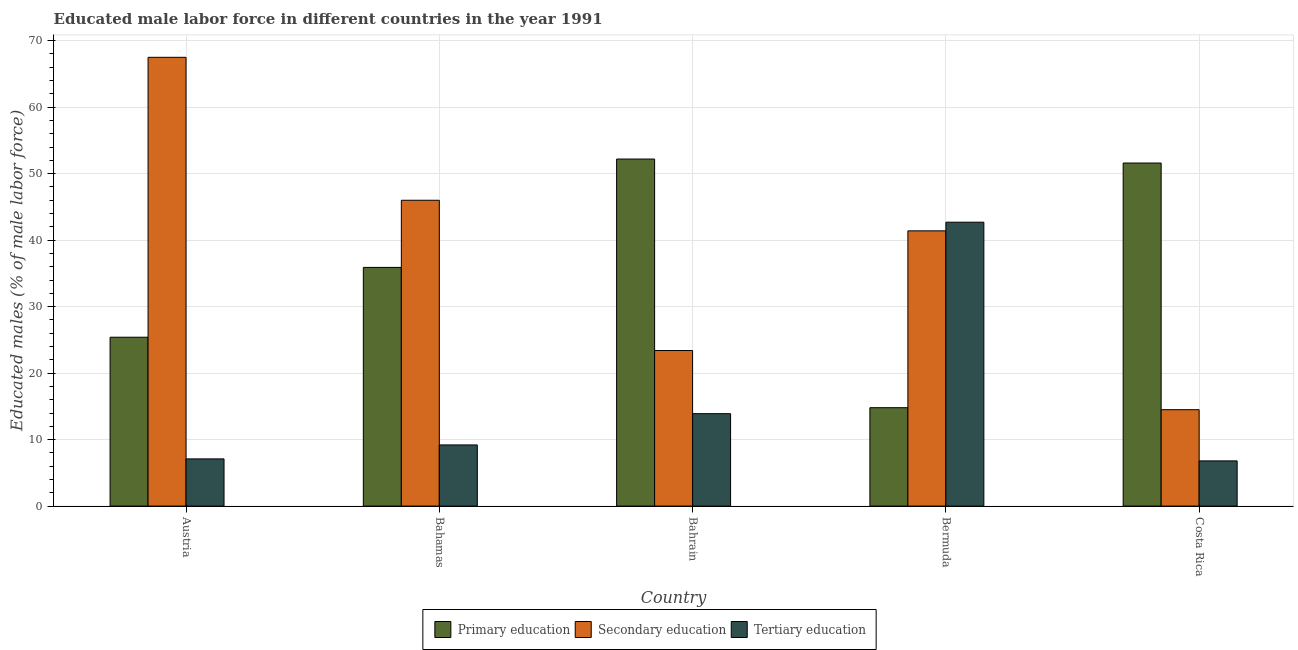What is the label of the 2nd group of bars from the left?
Give a very brief answer. Bahamas. What is the percentage of male labor force who received primary education in Austria?
Keep it short and to the point. 25.4. Across all countries, what is the maximum percentage of male labor force who received secondary education?
Provide a short and direct response. 67.5. Across all countries, what is the minimum percentage of male labor force who received primary education?
Ensure brevity in your answer.  14.8. In which country was the percentage of male labor force who received primary education maximum?
Your response must be concise. Bahrain. In which country was the percentage of male labor force who received secondary education minimum?
Your response must be concise. Costa Rica. What is the total percentage of male labor force who received secondary education in the graph?
Give a very brief answer. 192.8. What is the difference between the percentage of male labor force who received secondary education in Bermuda and the percentage of male labor force who received primary education in Austria?
Provide a succinct answer. 16. What is the average percentage of male labor force who received tertiary education per country?
Your answer should be very brief. 15.94. What is the difference between the percentage of male labor force who received primary education and percentage of male labor force who received tertiary education in Costa Rica?
Offer a terse response. 44.8. What is the ratio of the percentage of male labor force who received secondary education in Austria to that in Bermuda?
Keep it short and to the point. 1.63. Is the percentage of male labor force who received secondary education in Austria less than that in Bahrain?
Make the answer very short. No. Is the difference between the percentage of male labor force who received primary education in Bahamas and Costa Rica greater than the difference between the percentage of male labor force who received secondary education in Bahamas and Costa Rica?
Your answer should be very brief. No. What is the difference between the highest and the second highest percentage of male labor force who received tertiary education?
Your answer should be very brief. 28.8. In how many countries, is the percentage of male labor force who received secondary education greater than the average percentage of male labor force who received secondary education taken over all countries?
Provide a succinct answer. 3. Is the sum of the percentage of male labor force who received tertiary education in Bahamas and Bahrain greater than the maximum percentage of male labor force who received primary education across all countries?
Your answer should be compact. No. What does the 1st bar from the left in Austria represents?
Give a very brief answer. Primary education. What does the 1st bar from the right in Costa Rica represents?
Give a very brief answer. Tertiary education. How many countries are there in the graph?
Your answer should be compact. 5. What is the difference between two consecutive major ticks on the Y-axis?
Keep it short and to the point. 10. Are the values on the major ticks of Y-axis written in scientific E-notation?
Ensure brevity in your answer.  No. Does the graph contain any zero values?
Provide a short and direct response. No. Does the graph contain grids?
Your answer should be compact. Yes. How many legend labels are there?
Offer a terse response. 3. What is the title of the graph?
Your response must be concise. Educated male labor force in different countries in the year 1991. Does "Taxes on goods and services" appear as one of the legend labels in the graph?
Provide a short and direct response. No. What is the label or title of the Y-axis?
Provide a short and direct response. Educated males (% of male labor force). What is the Educated males (% of male labor force) of Primary education in Austria?
Provide a succinct answer. 25.4. What is the Educated males (% of male labor force) of Secondary education in Austria?
Offer a very short reply. 67.5. What is the Educated males (% of male labor force) in Tertiary education in Austria?
Give a very brief answer. 7.1. What is the Educated males (% of male labor force) of Primary education in Bahamas?
Offer a terse response. 35.9. What is the Educated males (% of male labor force) of Secondary education in Bahamas?
Your answer should be very brief. 46. What is the Educated males (% of male labor force) of Tertiary education in Bahamas?
Keep it short and to the point. 9.2. What is the Educated males (% of male labor force) in Primary education in Bahrain?
Offer a very short reply. 52.2. What is the Educated males (% of male labor force) in Secondary education in Bahrain?
Your answer should be compact. 23.4. What is the Educated males (% of male labor force) in Tertiary education in Bahrain?
Provide a short and direct response. 13.9. What is the Educated males (% of male labor force) of Primary education in Bermuda?
Your answer should be very brief. 14.8. What is the Educated males (% of male labor force) of Secondary education in Bermuda?
Offer a terse response. 41.4. What is the Educated males (% of male labor force) in Tertiary education in Bermuda?
Your answer should be very brief. 42.7. What is the Educated males (% of male labor force) in Primary education in Costa Rica?
Keep it short and to the point. 51.6. What is the Educated males (% of male labor force) of Secondary education in Costa Rica?
Provide a short and direct response. 14.5. What is the Educated males (% of male labor force) in Tertiary education in Costa Rica?
Provide a succinct answer. 6.8. Across all countries, what is the maximum Educated males (% of male labor force) in Primary education?
Your answer should be compact. 52.2. Across all countries, what is the maximum Educated males (% of male labor force) of Secondary education?
Provide a short and direct response. 67.5. Across all countries, what is the maximum Educated males (% of male labor force) of Tertiary education?
Provide a succinct answer. 42.7. Across all countries, what is the minimum Educated males (% of male labor force) in Primary education?
Ensure brevity in your answer.  14.8. Across all countries, what is the minimum Educated males (% of male labor force) in Secondary education?
Offer a very short reply. 14.5. Across all countries, what is the minimum Educated males (% of male labor force) of Tertiary education?
Your answer should be very brief. 6.8. What is the total Educated males (% of male labor force) in Primary education in the graph?
Keep it short and to the point. 179.9. What is the total Educated males (% of male labor force) in Secondary education in the graph?
Your answer should be very brief. 192.8. What is the total Educated males (% of male labor force) of Tertiary education in the graph?
Provide a succinct answer. 79.7. What is the difference between the Educated males (% of male labor force) in Primary education in Austria and that in Bahamas?
Your answer should be very brief. -10.5. What is the difference between the Educated males (% of male labor force) of Primary education in Austria and that in Bahrain?
Offer a terse response. -26.8. What is the difference between the Educated males (% of male labor force) in Secondary education in Austria and that in Bahrain?
Keep it short and to the point. 44.1. What is the difference between the Educated males (% of male labor force) of Primary education in Austria and that in Bermuda?
Give a very brief answer. 10.6. What is the difference between the Educated males (% of male labor force) of Secondary education in Austria and that in Bermuda?
Ensure brevity in your answer.  26.1. What is the difference between the Educated males (% of male labor force) in Tertiary education in Austria and that in Bermuda?
Your response must be concise. -35.6. What is the difference between the Educated males (% of male labor force) of Primary education in Austria and that in Costa Rica?
Offer a very short reply. -26.2. What is the difference between the Educated males (% of male labor force) in Primary education in Bahamas and that in Bahrain?
Ensure brevity in your answer.  -16.3. What is the difference between the Educated males (% of male labor force) of Secondary education in Bahamas and that in Bahrain?
Your answer should be very brief. 22.6. What is the difference between the Educated males (% of male labor force) in Tertiary education in Bahamas and that in Bahrain?
Offer a terse response. -4.7. What is the difference between the Educated males (% of male labor force) in Primary education in Bahamas and that in Bermuda?
Ensure brevity in your answer.  21.1. What is the difference between the Educated males (% of male labor force) in Tertiary education in Bahamas and that in Bermuda?
Your answer should be compact. -33.5. What is the difference between the Educated males (% of male labor force) of Primary education in Bahamas and that in Costa Rica?
Provide a short and direct response. -15.7. What is the difference between the Educated males (% of male labor force) of Secondary education in Bahamas and that in Costa Rica?
Provide a succinct answer. 31.5. What is the difference between the Educated males (% of male labor force) of Tertiary education in Bahamas and that in Costa Rica?
Keep it short and to the point. 2.4. What is the difference between the Educated males (% of male labor force) of Primary education in Bahrain and that in Bermuda?
Keep it short and to the point. 37.4. What is the difference between the Educated males (% of male labor force) of Secondary education in Bahrain and that in Bermuda?
Provide a succinct answer. -18. What is the difference between the Educated males (% of male labor force) of Tertiary education in Bahrain and that in Bermuda?
Provide a succinct answer. -28.8. What is the difference between the Educated males (% of male labor force) in Secondary education in Bahrain and that in Costa Rica?
Provide a succinct answer. 8.9. What is the difference between the Educated males (% of male labor force) of Tertiary education in Bahrain and that in Costa Rica?
Provide a short and direct response. 7.1. What is the difference between the Educated males (% of male labor force) in Primary education in Bermuda and that in Costa Rica?
Your answer should be very brief. -36.8. What is the difference between the Educated males (% of male labor force) in Secondary education in Bermuda and that in Costa Rica?
Offer a terse response. 26.9. What is the difference between the Educated males (% of male labor force) of Tertiary education in Bermuda and that in Costa Rica?
Offer a very short reply. 35.9. What is the difference between the Educated males (% of male labor force) in Primary education in Austria and the Educated males (% of male labor force) in Secondary education in Bahamas?
Your response must be concise. -20.6. What is the difference between the Educated males (% of male labor force) of Secondary education in Austria and the Educated males (% of male labor force) of Tertiary education in Bahamas?
Your response must be concise. 58.3. What is the difference between the Educated males (% of male labor force) in Primary education in Austria and the Educated males (% of male labor force) in Secondary education in Bahrain?
Keep it short and to the point. 2. What is the difference between the Educated males (% of male labor force) in Secondary education in Austria and the Educated males (% of male labor force) in Tertiary education in Bahrain?
Your answer should be very brief. 53.6. What is the difference between the Educated males (% of male labor force) of Primary education in Austria and the Educated males (% of male labor force) of Tertiary education in Bermuda?
Your response must be concise. -17.3. What is the difference between the Educated males (% of male labor force) of Secondary education in Austria and the Educated males (% of male labor force) of Tertiary education in Bermuda?
Give a very brief answer. 24.8. What is the difference between the Educated males (% of male labor force) of Primary education in Austria and the Educated males (% of male labor force) of Tertiary education in Costa Rica?
Provide a short and direct response. 18.6. What is the difference between the Educated males (% of male labor force) in Secondary education in Austria and the Educated males (% of male labor force) in Tertiary education in Costa Rica?
Offer a very short reply. 60.7. What is the difference between the Educated males (% of male labor force) of Primary education in Bahamas and the Educated males (% of male labor force) of Secondary education in Bahrain?
Your answer should be very brief. 12.5. What is the difference between the Educated males (% of male labor force) in Primary education in Bahamas and the Educated males (% of male labor force) in Tertiary education in Bahrain?
Provide a short and direct response. 22. What is the difference between the Educated males (% of male labor force) in Secondary education in Bahamas and the Educated males (% of male labor force) in Tertiary education in Bahrain?
Ensure brevity in your answer.  32.1. What is the difference between the Educated males (% of male labor force) of Primary education in Bahamas and the Educated males (% of male labor force) of Secondary education in Bermuda?
Your response must be concise. -5.5. What is the difference between the Educated males (% of male labor force) of Primary education in Bahamas and the Educated males (% of male labor force) of Tertiary education in Bermuda?
Provide a succinct answer. -6.8. What is the difference between the Educated males (% of male labor force) of Secondary education in Bahamas and the Educated males (% of male labor force) of Tertiary education in Bermuda?
Ensure brevity in your answer.  3.3. What is the difference between the Educated males (% of male labor force) in Primary education in Bahamas and the Educated males (% of male labor force) in Secondary education in Costa Rica?
Your response must be concise. 21.4. What is the difference between the Educated males (% of male labor force) in Primary education in Bahamas and the Educated males (% of male labor force) in Tertiary education in Costa Rica?
Keep it short and to the point. 29.1. What is the difference between the Educated males (% of male labor force) in Secondary education in Bahamas and the Educated males (% of male labor force) in Tertiary education in Costa Rica?
Provide a succinct answer. 39.2. What is the difference between the Educated males (% of male labor force) in Secondary education in Bahrain and the Educated males (% of male labor force) in Tertiary education in Bermuda?
Provide a short and direct response. -19.3. What is the difference between the Educated males (% of male labor force) in Primary education in Bahrain and the Educated males (% of male labor force) in Secondary education in Costa Rica?
Offer a terse response. 37.7. What is the difference between the Educated males (% of male labor force) in Primary education in Bahrain and the Educated males (% of male labor force) in Tertiary education in Costa Rica?
Make the answer very short. 45.4. What is the difference between the Educated males (% of male labor force) in Secondary education in Bahrain and the Educated males (% of male labor force) in Tertiary education in Costa Rica?
Offer a terse response. 16.6. What is the difference between the Educated males (% of male labor force) of Secondary education in Bermuda and the Educated males (% of male labor force) of Tertiary education in Costa Rica?
Your response must be concise. 34.6. What is the average Educated males (% of male labor force) of Primary education per country?
Your response must be concise. 35.98. What is the average Educated males (% of male labor force) of Secondary education per country?
Your response must be concise. 38.56. What is the average Educated males (% of male labor force) of Tertiary education per country?
Your answer should be compact. 15.94. What is the difference between the Educated males (% of male labor force) in Primary education and Educated males (% of male labor force) in Secondary education in Austria?
Make the answer very short. -42.1. What is the difference between the Educated males (% of male labor force) of Secondary education and Educated males (% of male labor force) of Tertiary education in Austria?
Your answer should be compact. 60.4. What is the difference between the Educated males (% of male labor force) in Primary education and Educated males (% of male labor force) in Secondary education in Bahamas?
Make the answer very short. -10.1. What is the difference between the Educated males (% of male labor force) in Primary education and Educated males (% of male labor force) in Tertiary education in Bahamas?
Your answer should be compact. 26.7. What is the difference between the Educated males (% of male labor force) of Secondary education and Educated males (% of male labor force) of Tertiary education in Bahamas?
Keep it short and to the point. 36.8. What is the difference between the Educated males (% of male labor force) of Primary education and Educated males (% of male labor force) of Secondary education in Bahrain?
Your answer should be very brief. 28.8. What is the difference between the Educated males (% of male labor force) in Primary education and Educated males (% of male labor force) in Tertiary education in Bahrain?
Ensure brevity in your answer.  38.3. What is the difference between the Educated males (% of male labor force) in Secondary education and Educated males (% of male labor force) in Tertiary education in Bahrain?
Keep it short and to the point. 9.5. What is the difference between the Educated males (% of male labor force) in Primary education and Educated males (% of male labor force) in Secondary education in Bermuda?
Make the answer very short. -26.6. What is the difference between the Educated males (% of male labor force) of Primary education and Educated males (% of male labor force) of Tertiary education in Bermuda?
Make the answer very short. -27.9. What is the difference between the Educated males (% of male labor force) in Secondary education and Educated males (% of male labor force) in Tertiary education in Bermuda?
Make the answer very short. -1.3. What is the difference between the Educated males (% of male labor force) of Primary education and Educated males (% of male labor force) of Secondary education in Costa Rica?
Make the answer very short. 37.1. What is the difference between the Educated males (% of male labor force) in Primary education and Educated males (% of male labor force) in Tertiary education in Costa Rica?
Give a very brief answer. 44.8. What is the difference between the Educated males (% of male labor force) in Secondary education and Educated males (% of male labor force) in Tertiary education in Costa Rica?
Your response must be concise. 7.7. What is the ratio of the Educated males (% of male labor force) in Primary education in Austria to that in Bahamas?
Your answer should be very brief. 0.71. What is the ratio of the Educated males (% of male labor force) in Secondary education in Austria to that in Bahamas?
Offer a terse response. 1.47. What is the ratio of the Educated males (% of male labor force) of Tertiary education in Austria to that in Bahamas?
Ensure brevity in your answer.  0.77. What is the ratio of the Educated males (% of male labor force) of Primary education in Austria to that in Bahrain?
Ensure brevity in your answer.  0.49. What is the ratio of the Educated males (% of male labor force) of Secondary education in Austria to that in Bahrain?
Keep it short and to the point. 2.88. What is the ratio of the Educated males (% of male labor force) in Tertiary education in Austria to that in Bahrain?
Provide a succinct answer. 0.51. What is the ratio of the Educated males (% of male labor force) in Primary education in Austria to that in Bermuda?
Your answer should be very brief. 1.72. What is the ratio of the Educated males (% of male labor force) of Secondary education in Austria to that in Bermuda?
Provide a short and direct response. 1.63. What is the ratio of the Educated males (% of male labor force) of Tertiary education in Austria to that in Bermuda?
Provide a succinct answer. 0.17. What is the ratio of the Educated males (% of male labor force) in Primary education in Austria to that in Costa Rica?
Give a very brief answer. 0.49. What is the ratio of the Educated males (% of male labor force) of Secondary education in Austria to that in Costa Rica?
Keep it short and to the point. 4.66. What is the ratio of the Educated males (% of male labor force) of Tertiary education in Austria to that in Costa Rica?
Ensure brevity in your answer.  1.04. What is the ratio of the Educated males (% of male labor force) in Primary education in Bahamas to that in Bahrain?
Your answer should be very brief. 0.69. What is the ratio of the Educated males (% of male labor force) in Secondary education in Bahamas to that in Bahrain?
Offer a very short reply. 1.97. What is the ratio of the Educated males (% of male labor force) of Tertiary education in Bahamas to that in Bahrain?
Your answer should be very brief. 0.66. What is the ratio of the Educated males (% of male labor force) in Primary education in Bahamas to that in Bermuda?
Ensure brevity in your answer.  2.43. What is the ratio of the Educated males (% of male labor force) of Tertiary education in Bahamas to that in Bermuda?
Your answer should be compact. 0.22. What is the ratio of the Educated males (% of male labor force) of Primary education in Bahamas to that in Costa Rica?
Provide a succinct answer. 0.7. What is the ratio of the Educated males (% of male labor force) in Secondary education in Bahamas to that in Costa Rica?
Offer a very short reply. 3.17. What is the ratio of the Educated males (% of male labor force) of Tertiary education in Bahamas to that in Costa Rica?
Your answer should be compact. 1.35. What is the ratio of the Educated males (% of male labor force) in Primary education in Bahrain to that in Bermuda?
Your answer should be compact. 3.53. What is the ratio of the Educated males (% of male labor force) in Secondary education in Bahrain to that in Bermuda?
Give a very brief answer. 0.57. What is the ratio of the Educated males (% of male labor force) in Tertiary education in Bahrain to that in Bermuda?
Provide a succinct answer. 0.33. What is the ratio of the Educated males (% of male labor force) in Primary education in Bahrain to that in Costa Rica?
Provide a short and direct response. 1.01. What is the ratio of the Educated males (% of male labor force) in Secondary education in Bahrain to that in Costa Rica?
Offer a very short reply. 1.61. What is the ratio of the Educated males (% of male labor force) of Tertiary education in Bahrain to that in Costa Rica?
Your answer should be very brief. 2.04. What is the ratio of the Educated males (% of male labor force) in Primary education in Bermuda to that in Costa Rica?
Offer a very short reply. 0.29. What is the ratio of the Educated males (% of male labor force) in Secondary education in Bermuda to that in Costa Rica?
Your answer should be compact. 2.86. What is the ratio of the Educated males (% of male labor force) in Tertiary education in Bermuda to that in Costa Rica?
Offer a terse response. 6.28. What is the difference between the highest and the second highest Educated males (% of male labor force) of Primary education?
Provide a succinct answer. 0.6. What is the difference between the highest and the second highest Educated males (% of male labor force) of Tertiary education?
Keep it short and to the point. 28.8. What is the difference between the highest and the lowest Educated males (% of male labor force) in Primary education?
Keep it short and to the point. 37.4. What is the difference between the highest and the lowest Educated males (% of male labor force) of Secondary education?
Keep it short and to the point. 53. What is the difference between the highest and the lowest Educated males (% of male labor force) in Tertiary education?
Provide a short and direct response. 35.9. 